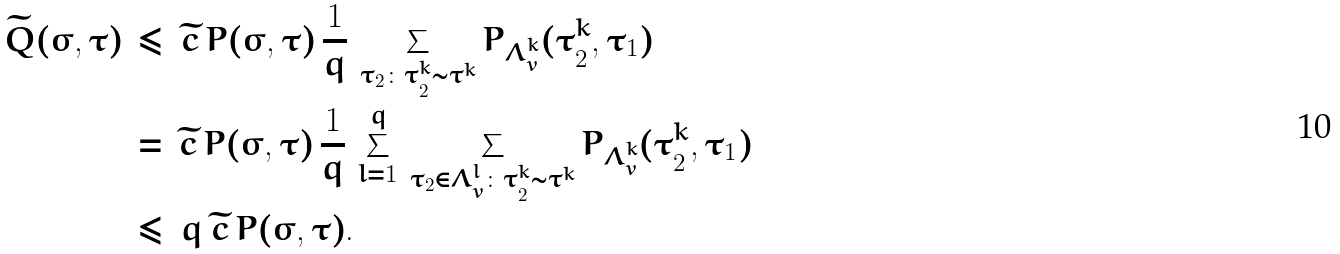<formula> <loc_0><loc_0><loc_500><loc_500>\widetilde { Q } ( \sigma , \tau ) \, & \leq \, \widetilde { c } \, P ( \sigma , \tau ) \, \frac { 1 } { q } \, \sum _ { \tau _ { 2 } \colon \tau _ { 2 } ^ { k } \sim \tau ^ { k } } P _ { \Lambda _ { v } ^ { k } } ( \tau _ { 2 } ^ { k } , \tau _ { 1 } ) \\ \, & = \, \widetilde { c } \, P ( \sigma , \tau ) \, \frac { 1 } { q } \, \sum _ { l = 1 } ^ { q } \, \sum _ { \tau _ { 2 } \in \Lambda _ { v } ^ { l } \colon \tau _ { 2 } ^ { k } \sim \tau ^ { k } } P _ { \Lambda _ { v } ^ { k } } ( \tau _ { 2 } ^ { k } , \tau _ { 1 } ) \\ \, & \leq \, q \, \widetilde { c } \, P ( \sigma , \tau ) .</formula> 